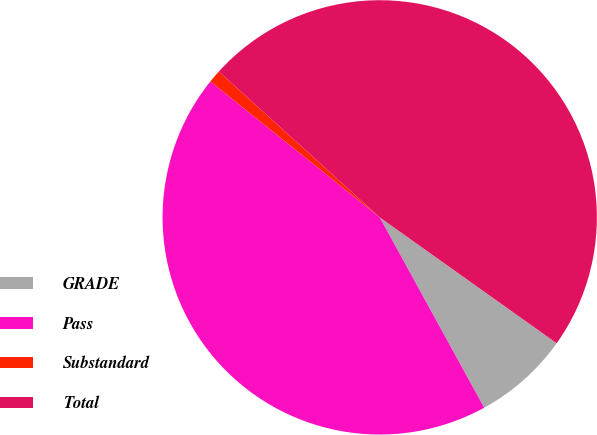Convert chart to OTSL. <chart><loc_0><loc_0><loc_500><loc_500><pie_chart><fcel>GRADE<fcel>Pass<fcel>Substandard<fcel>Total<nl><fcel>7.17%<fcel>43.75%<fcel>0.96%<fcel>48.12%<nl></chart> 